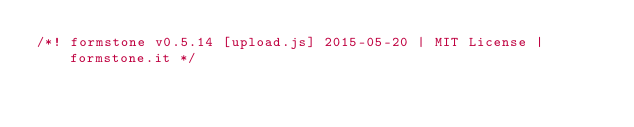<code> <loc_0><loc_0><loc_500><loc_500><_JavaScript_>/*! formstone v0.5.14 [upload.js] 2015-05-20 | MIT License | formstone.it */
</code> 